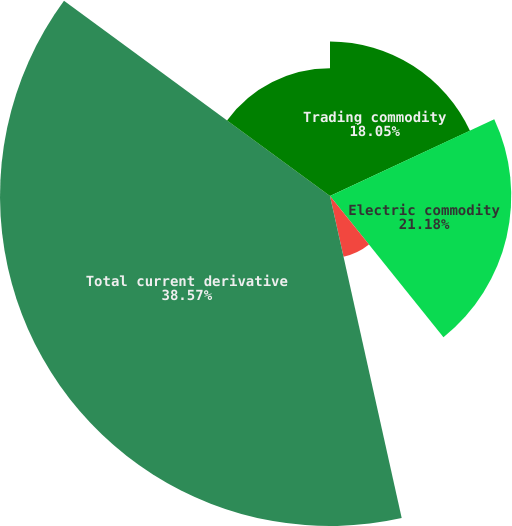Convert chart to OTSL. <chart><loc_0><loc_0><loc_500><loc_500><pie_chart><fcel>Trading commodity<fcel>Electric commodity<fcel>Natural gas commodity<fcel>Total current derivative<fcel>Total noncurrent derivative<nl><fcel>18.05%<fcel>21.18%<fcel>7.28%<fcel>38.56%<fcel>14.92%<nl></chart> 